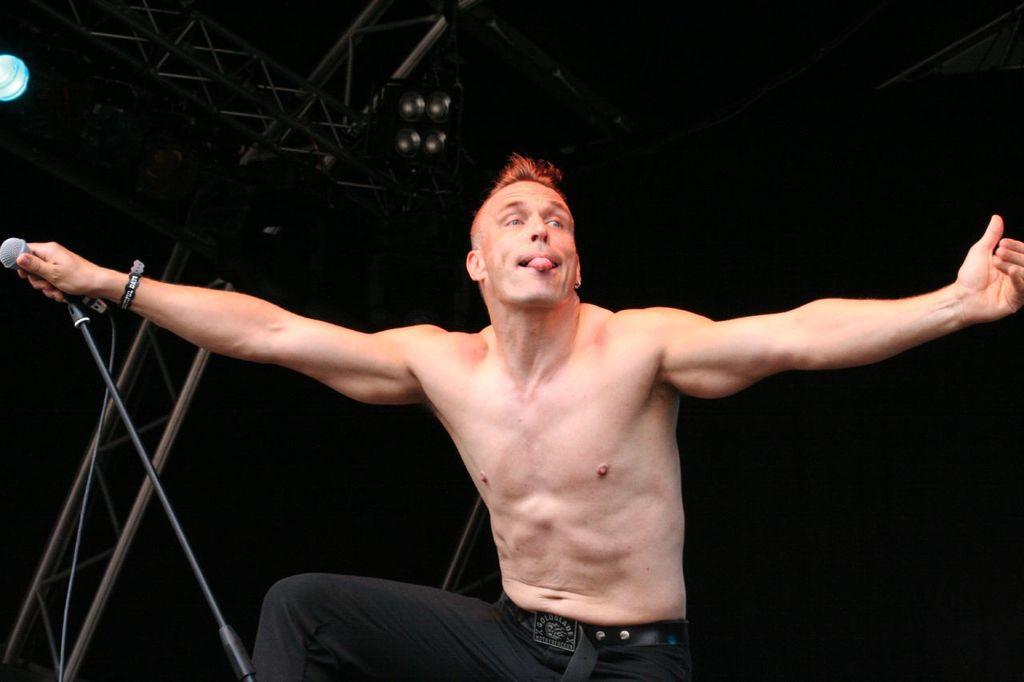Could you give a brief overview of what you see in this image? In this image in the center there is one person who is standing and he is holding a mike, in the background there are some poles and at the top there are some lights. 